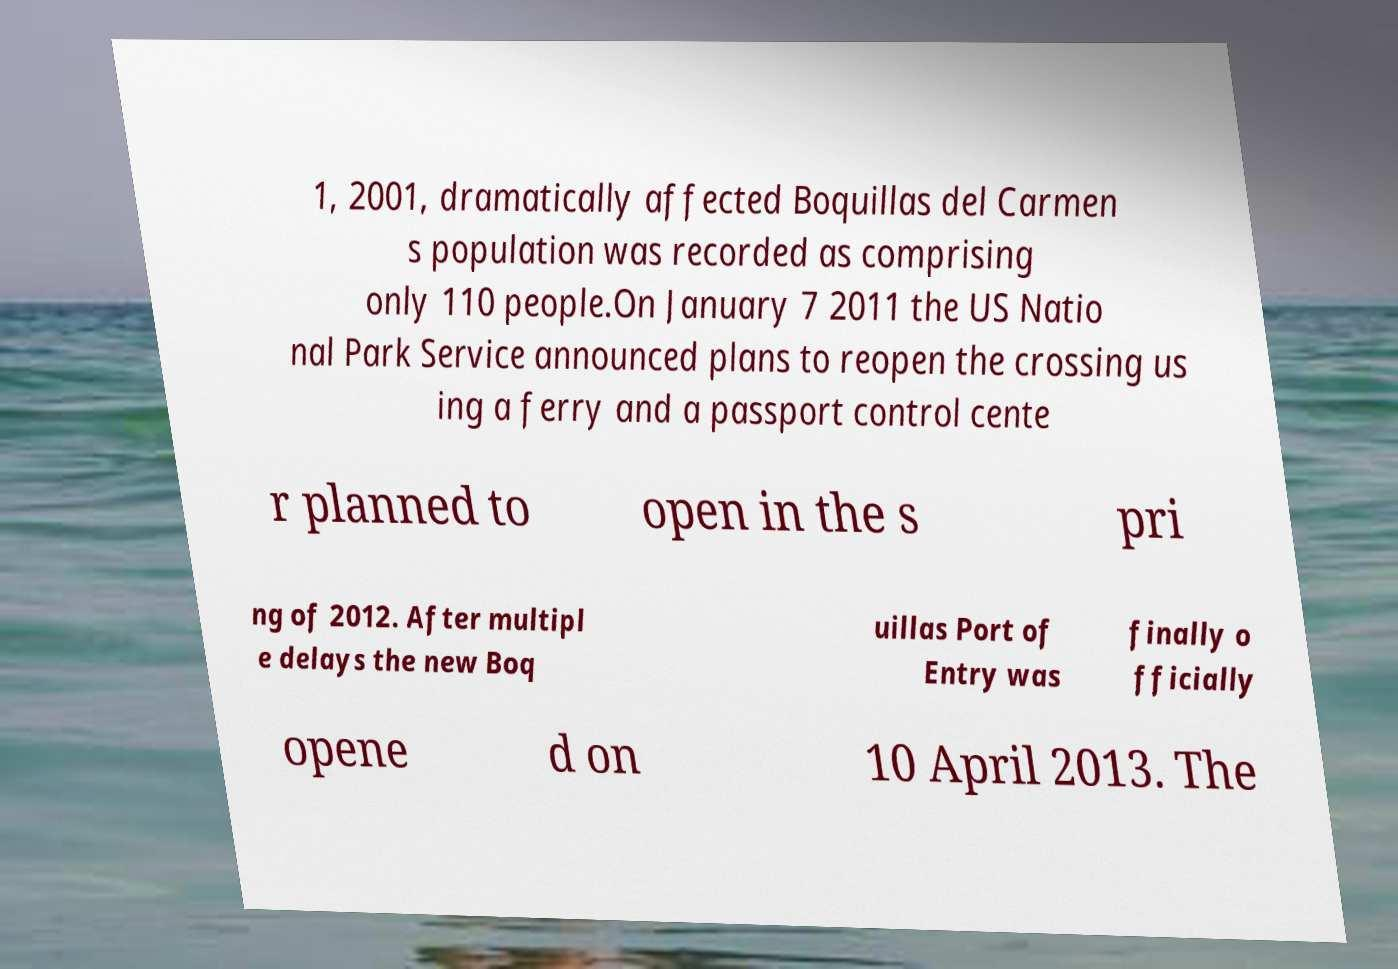What messages or text are displayed in this image? I need them in a readable, typed format. 1, 2001, dramatically affected Boquillas del Carmen s population was recorded as comprising only 110 people.On January 7 2011 the US Natio nal Park Service announced plans to reopen the crossing us ing a ferry and a passport control cente r planned to open in the s pri ng of 2012. After multipl e delays the new Boq uillas Port of Entry was finally o fficially opene d on 10 April 2013. The 